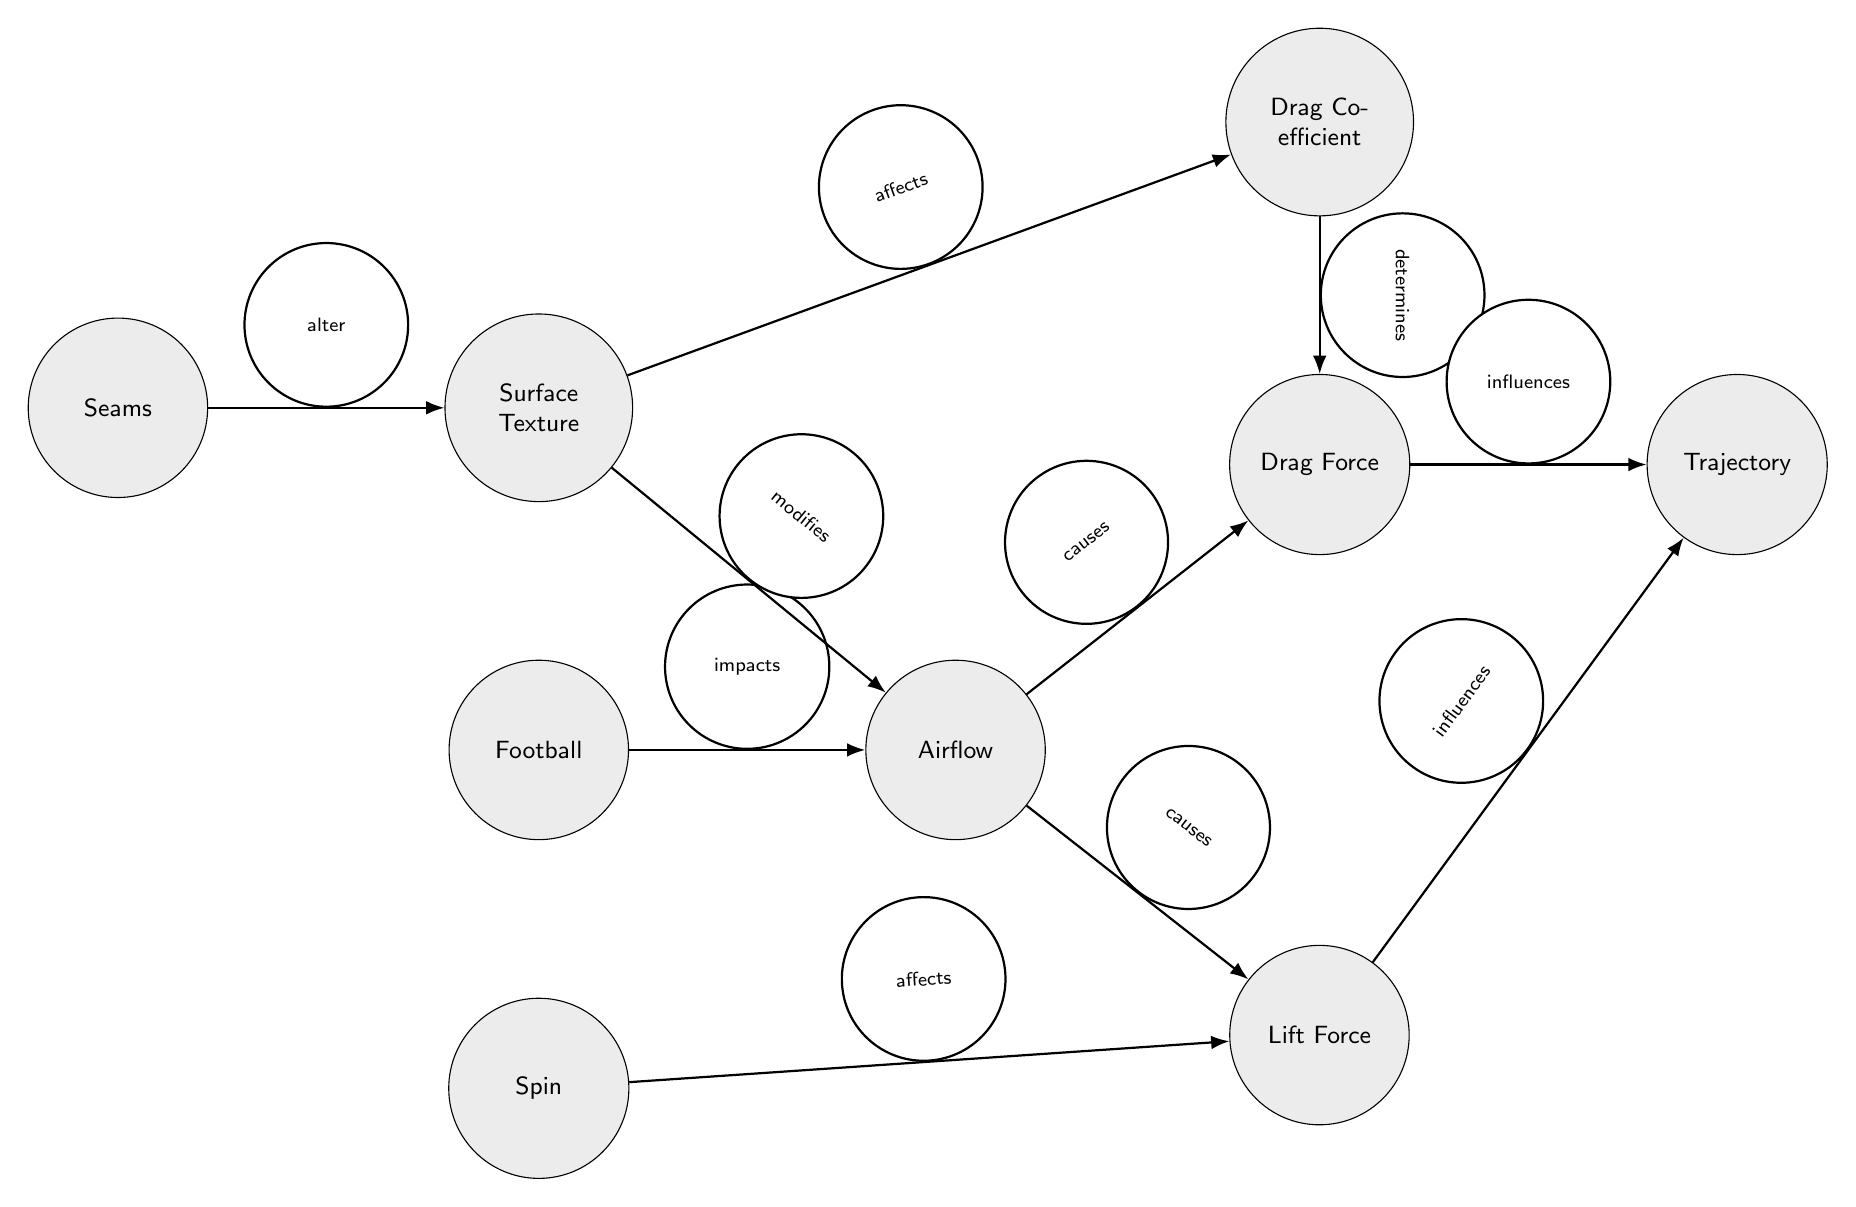What is the main object represented in the diagram? The central focus of the diagram is the node labeled "Football," which is visually at the center of the flow, indicating that it is the primary object being studied in relation to airflow dynamics.
Answer: Football How many edges connect to the "Airflow" node? The "Airflow" node has two edges stemming from it, which connect to the "Drag Force" and "Lift Force" nodes, indicating its dual impact on different forces in the system.
Answer: 2 What effect does "Surface Texture" have on "Drag Coefficient"? The diagram shows a directed edge from "Surface Texture" to "Drag Coefficient," labeled "affects," which signifies that changes in surface texture will directly influence the drag coefficient.
Answer: affects Which force influences the "Trajectory" node? Both "Lift Force" and "Drag Force" have directed edges leading to "Trajectory," indicating that they both significantly influence the path or trajectory of the football during flight.
Answer: Lift Force, Drag Force Which feature of the football alters the "Surface Texture"? The diagram indicates that "Seams" modify the "Surface Texture" through a directed edge labeled "alter," meaning that football seams play a crucial role in changing how the surface interacts with airflow.
Answer: Seams What determines the "Drag Force"? The "Drag Coefficient" node influences the "Drag Force" node as per the directed edge labeled "determines," signifying that the drag coefficient is a critical factor in calculating drag force on the football.
Answer: Drag Coefficient How does "Spin" affect the forces acting on the football? The edge directed from "Spin" to "Lift Force" illustrates that the spin applied to the football affects the lift force created during its flight, which is a key factor in its trajectory.
Answer: affects What is the relationship between airflows and the forces acting on the football? "Airflow" causes both "Drag Force" and "Lift Force," illustrating a direct cause-effect relationship where airflow dynamics directly influence the forces acting on the football.
Answer: causes How does "Surface Texture" modify the "Airflow"? The flow diagram shows an edge from "Surface Texture" to "Airflow," labeled "modifies," indicating that different textures will change the way airflow interacts with the football’s surface.
Answer: modifies 